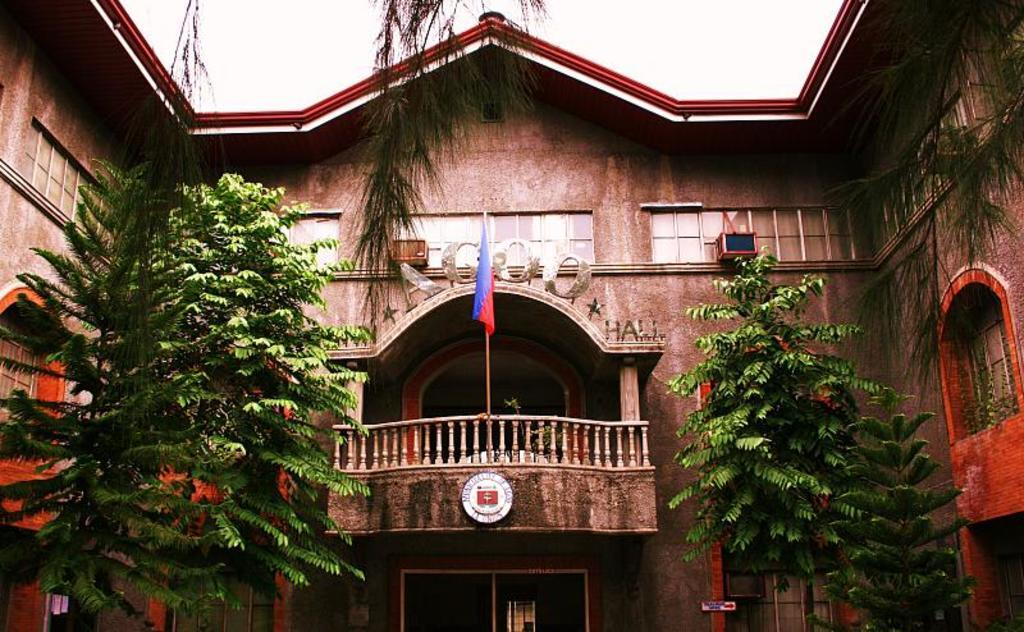What type of vegetation is in front of the building in the image? There are trees in front of the building in the image. What can be seen in the middle of the image? There is a flag in the middle of the image. What is visible at the top of the image? The sky is visible at the top of the image. Can you see the head of the person holding the whip in the image? There is no person holding a whip present in the image. 